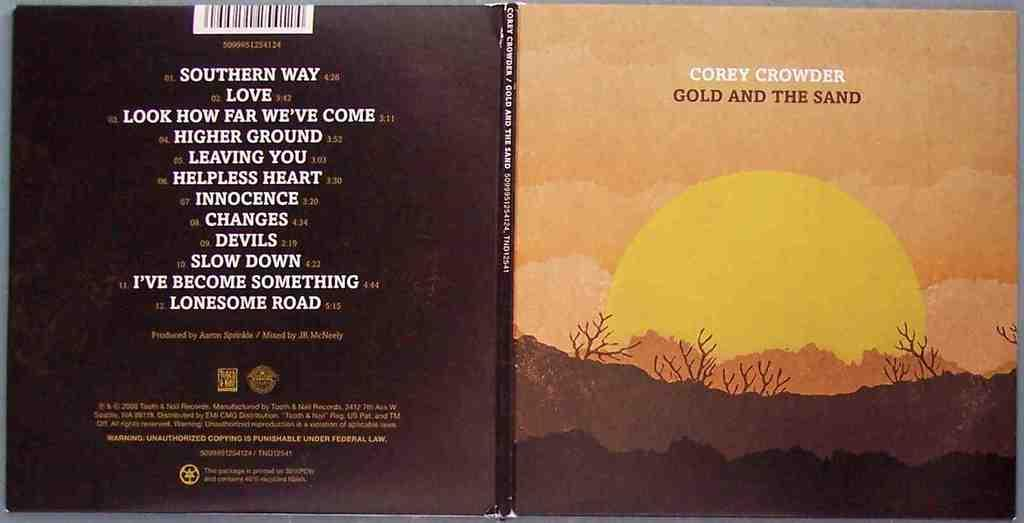<image>
Relay a brief, clear account of the picture shown. a book that is called Gold and the Sand 